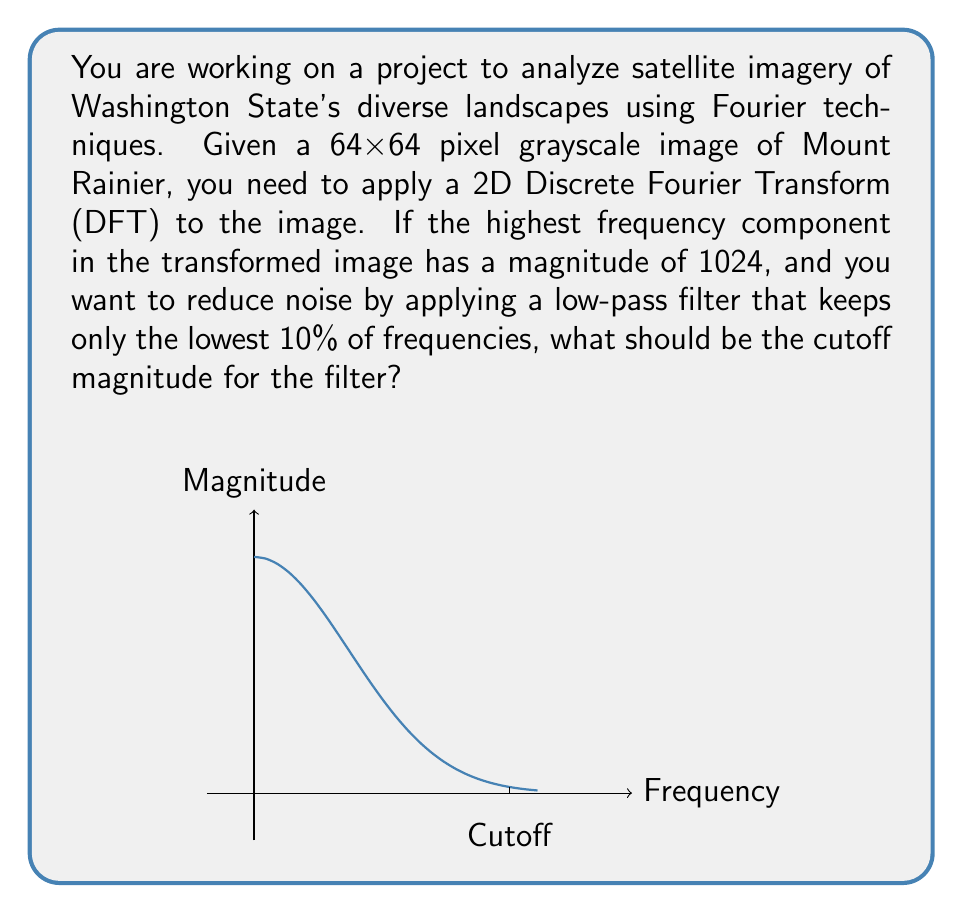Solve this math problem. Let's approach this step-by-step:

1) The 2D DFT of an NxN image produces an NxN frequency domain representation. In this case, we have a 64x64 image, so the output will also be 64x64.

2) The total number of frequency components is 64 * 64 = 4096.

3) We want to keep the lowest 10% of frequencies. This means we need to keep:
   $$ 4096 * 0.1 = 409.6 $$
   Rounding down, we'll keep 409 frequency components.

4) To find the cutoff magnitude, we need to determine the 409th highest magnitude in the frequency domain.

5) In a typical image, the magnitude of frequency components often follows a power law distribution, with the highest magnitudes at low frequencies and rapidly decreasing magnitudes at higher frequencies.

6) Given that the highest magnitude is 1024, we can estimate the cutoff magnitude using a logarithmic scale:

   $$ \text{Cutoff Magnitude} = 1024 * (\frac{409}{4096})^k $$

   where k is a factor that determines how quickly the magnitudes fall off.

7) For natural images, k is often around 2. Let's use this value:

   $$ \text{Cutoff Magnitude} = 1024 * (\frac{409}{4096})^2 $$
   $$ = 1024 * (0.0999)^2 $$
   $$ = 1024 * 0.00998 $$
   $$ = 10.22 $$

8) Rounding to a reasonable precision for this application, we get a cutoff magnitude of 10.

This cutoff magnitude will allow us to keep approximately the lowest 10% of frequencies, which should preserve the main features of Mount Rainier while reducing high-frequency noise in the image.
Answer: 10 